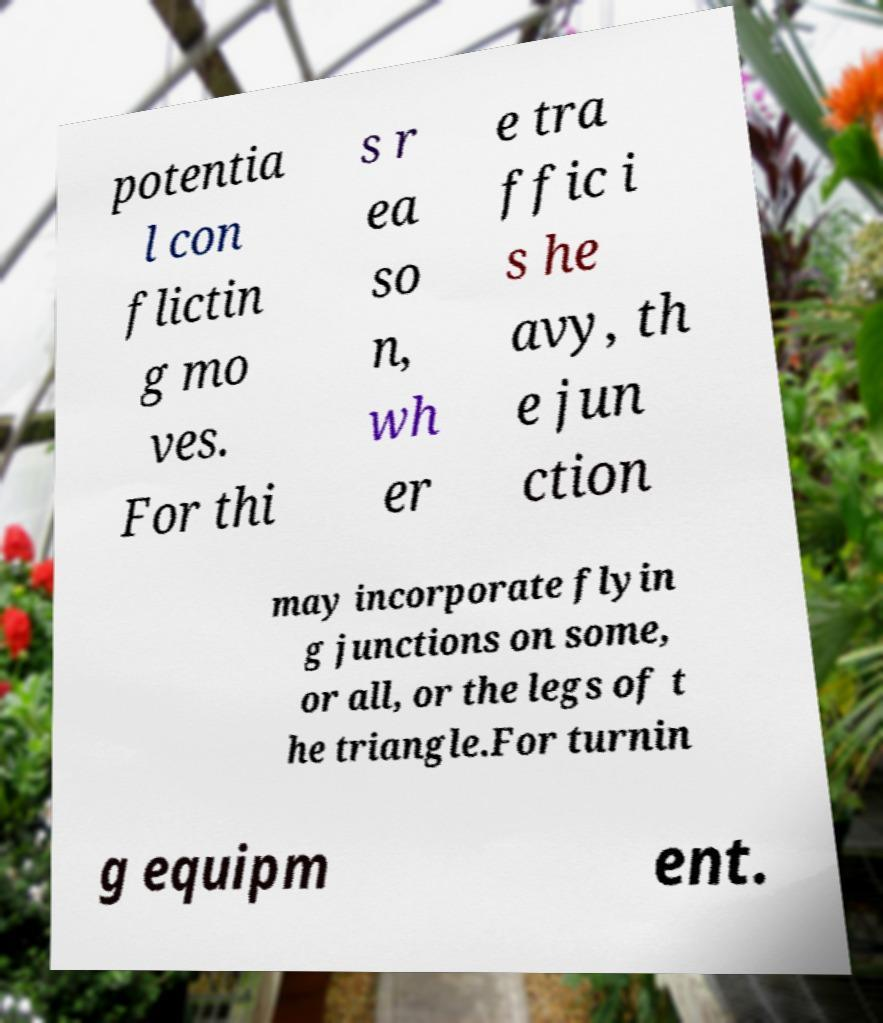I need the written content from this picture converted into text. Can you do that? potentia l con flictin g mo ves. For thi s r ea so n, wh er e tra ffic i s he avy, th e jun ction may incorporate flyin g junctions on some, or all, or the legs of t he triangle.For turnin g equipm ent. 